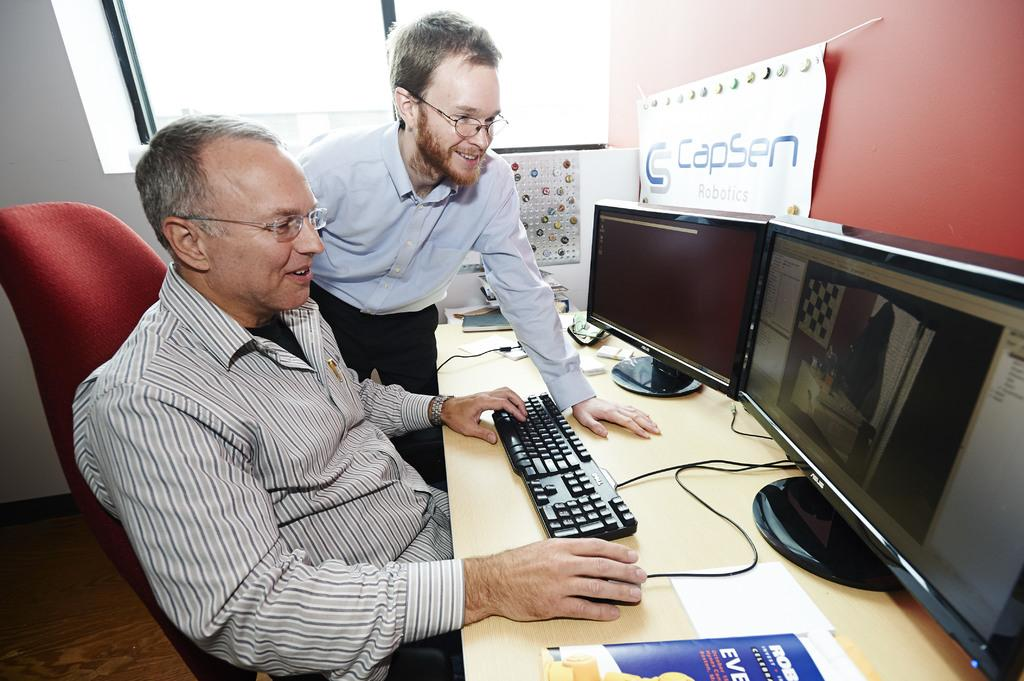<image>
Render a clear and concise summary of the photo. Two people from CapSen Robotics work together at a computer. 